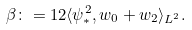<formula> <loc_0><loc_0><loc_500><loc_500>\beta \colon = 1 2 \langle \psi _ { * } ^ { 2 } , w _ { 0 } + w _ { 2 } \rangle _ { L ^ { 2 } } .</formula> 